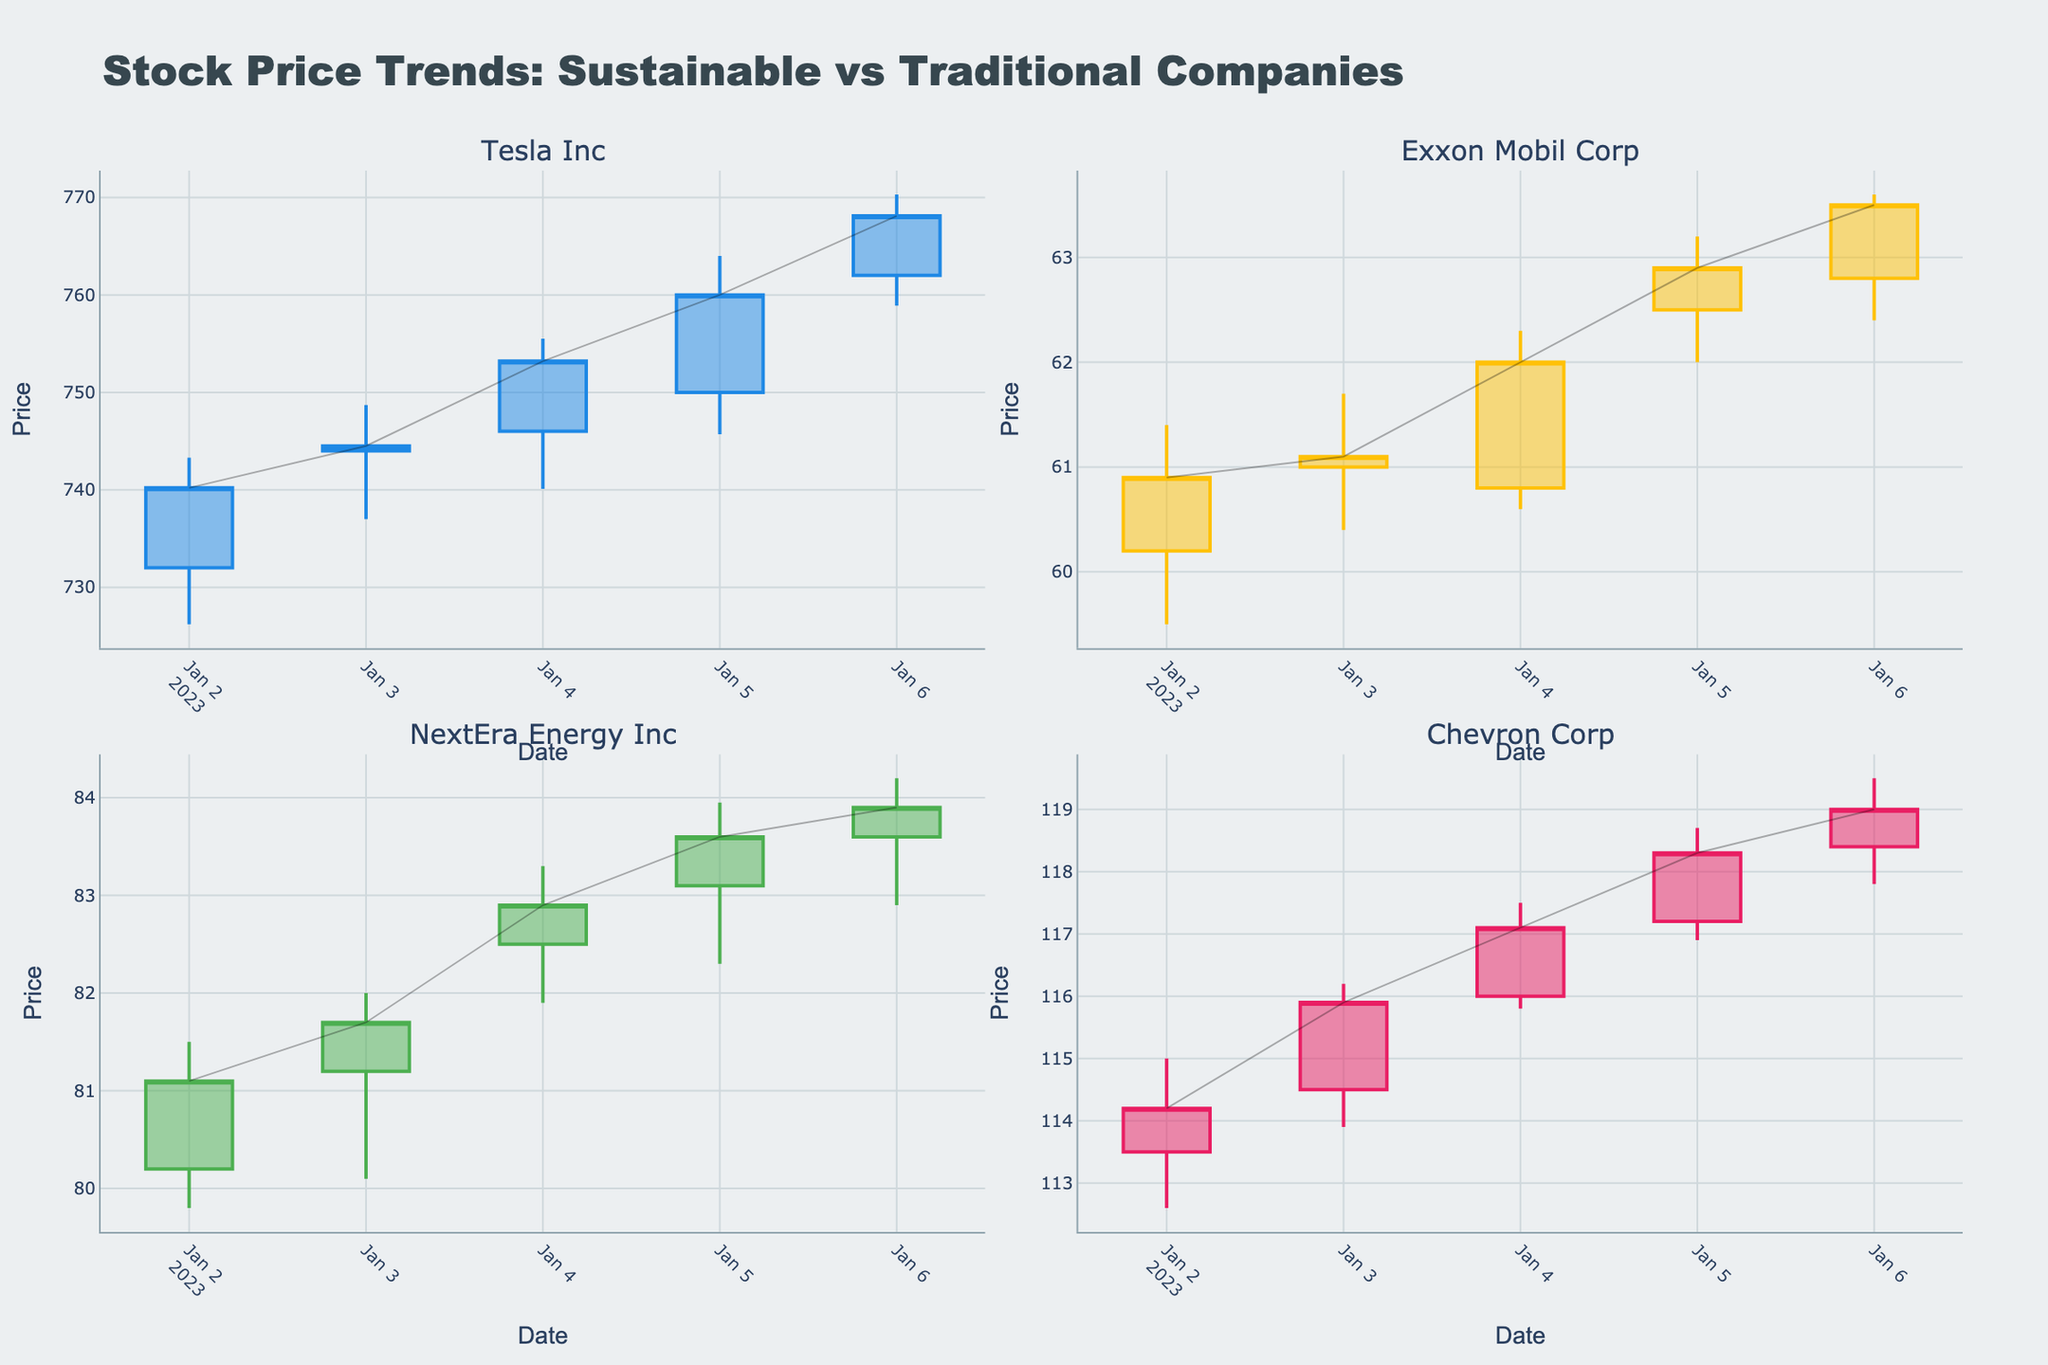What are the names of the four companies plotted in the figure? The subplot titles indicate the names of the companies included in the figure. Those titles are displayed at the top of each subplot.
Answer: Tesla Inc, Exxon Mobil Corp, NextEra Energy Inc, Chevron Corp Which company's stock price closed higher on January 2, Tesla Inc or Exxon Mobil Corp? To find which stock closed higher on January 2, look at the "Close" price for both Tesla Inc and Exxon Mobil Corp on that date. Tesla Inc closed at 740.20, and Exxon Mobil Corp closed at 60.90.
Answer: Tesla Inc On January 4, which company had the highest closing stock price among all four companies? Examine each company's closing price on January 4 by checking the respective candlestick for that date. The closing prices are 753.20 for Tesla Inc, 62.00 for Exxon Mobil Corp, 82.90 for NextEra Energy Inc, and 117.10 for Chevron Corp.
Answer: Chevron Corp What was the stock price range (difference between high and low prices) for NextEra Energy Inc on January 5? Look at the candlestick for NextEra Energy Inc on January 5, and find the high and low prices. The high was 83.95, and the low was 82.30. Subtract the low from the high: 83.95 - 82.30 = 1.65.
Answer: 1.65 Which of the four companies showed an increasing trend in their stock price from January 2 to January 6? To determine the trend from January 2 to January 6, observe each company's closing prices on these dates. If the closing prices increased over these days, the company showed an increasing trend.
Answer: Tesla Inc, NextEra Energy Inc, Chevron Corp Compare the closing prices of Tesla Inc and Chevron Corp on January 6. Which company had a higher closing price? On January 6, check the closing prices for Tesla Inc and Chevron Corp. Tesla Inc closed at 768.10, while Chevron Corp closed at 119.00.
Answer: Tesla Inc How many candlestick charts are present in the figure? Identify the number of subplots containing candlestick charts. Since each subplot represents a company, and there are four companies, there are four candlestick charts.
Answer: Four During the observed period, which company had the highest trading volume, and on which date did this occur? Review the 'Volume' data for all companies over the period. Find the highest volume and the corresponding date. For example, the highest volume is 4,885,300 for Tesla Inc on January 6.
Answer: Tesla Inc, January 6 